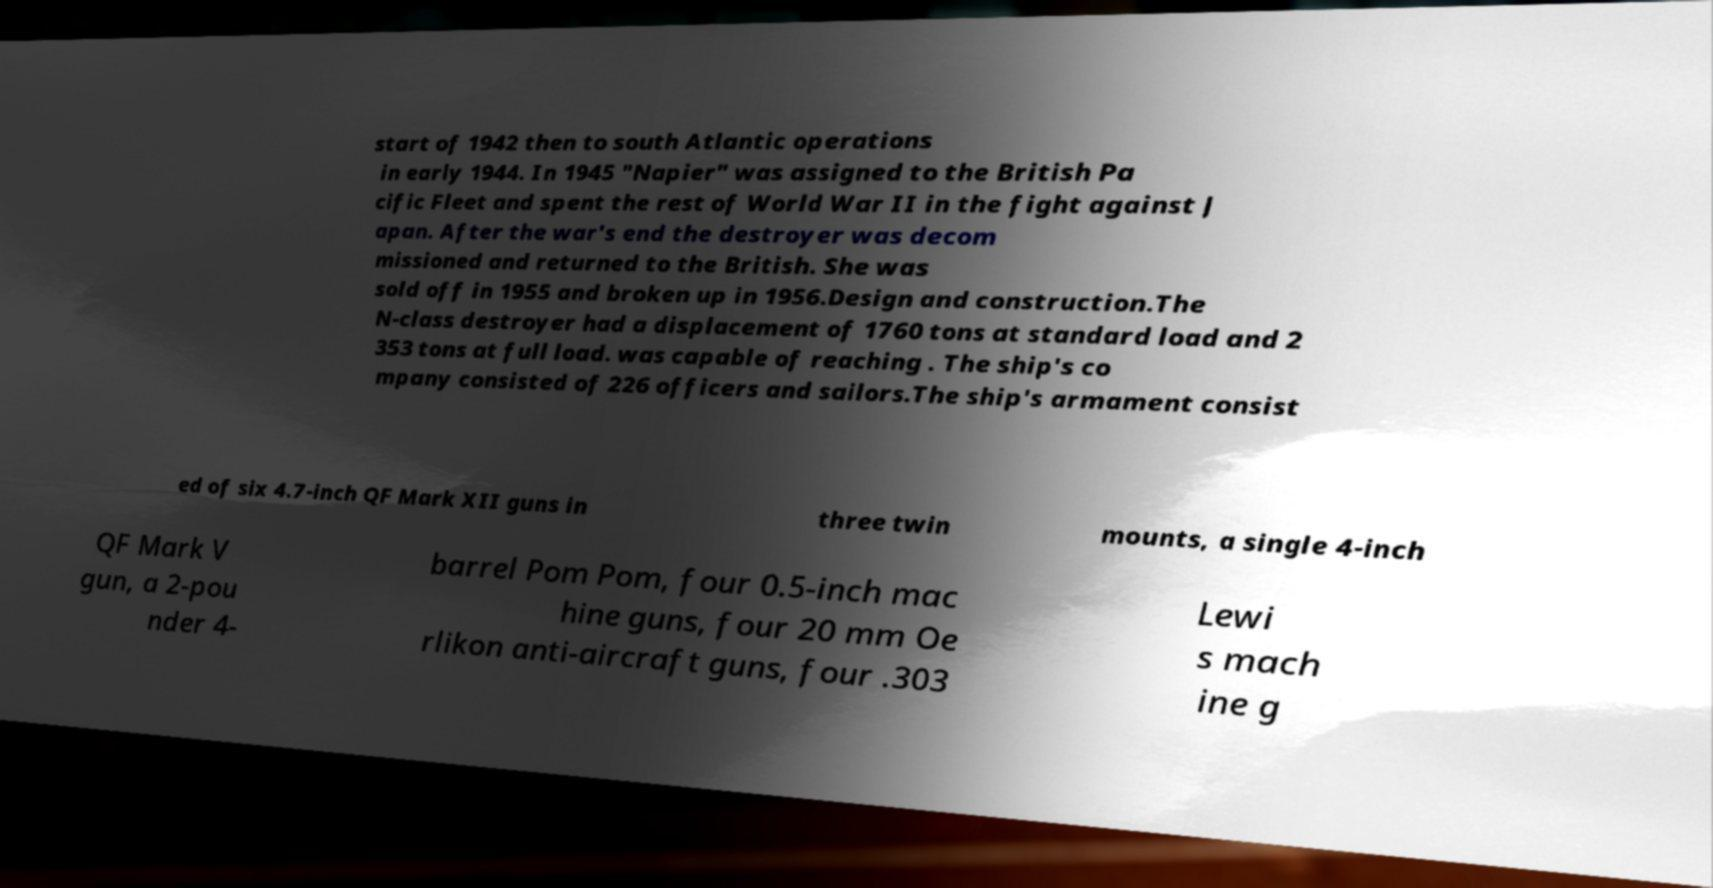Please identify and transcribe the text found in this image. start of 1942 then to south Atlantic operations in early 1944. In 1945 "Napier" was assigned to the British Pa cific Fleet and spent the rest of World War II in the fight against J apan. After the war's end the destroyer was decom missioned and returned to the British. She was sold off in 1955 and broken up in 1956.Design and construction.The N-class destroyer had a displacement of 1760 tons at standard load and 2 353 tons at full load. was capable of reaching . The ship's co mpany consisted of 226 officers and sailors.The ship's armament consist ed of six 4.7-inch QF Mark XII guns in three twin mounts, a single 4-inch QF Mark V gun, a 2-pou nder 4- barrel Pom Pom, four 0.5-inch mac hine guns, four 20 mm Oe rlikon anti-aircraft guns, four .303 Lewi s mach ine g 